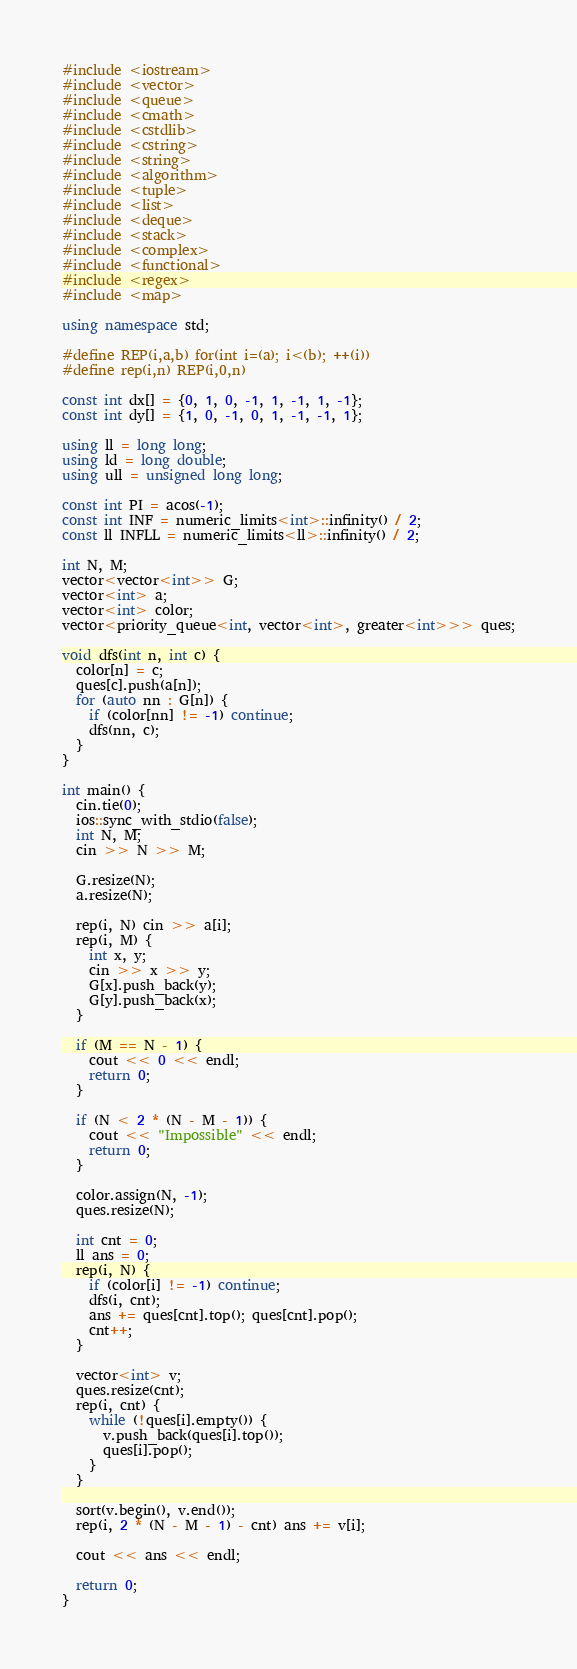<code> <loc_0><loc_0><loc_500><loc_500><_C++_>#include <iostream>
#include <vector>
#include <queue>
#include <cmath>
#include <cstdlib>
#include <cstring>
#include <string>
#include <algorithm>
#include <tuple>
#include <list>
#include <deque>
#include <stack>
#include <complex>
#include <functional>
#include <regex>
#include <map>

using namespace std;

#define REP(i,a,b) for(int i=(a); i<(b); ++(i))
#define rep(i,n) REP(i,0,n)

const int dx[] = {0, 1, 0, -1, 1, -1, 1, -1};
const int dy[] = {1, 0, -1, 0, 1, -1, -1, 1};

using ll = long long;
using ld = long double;
using ull = unsigned long long;

const int PI = acos(-1);
const int INF = numeric_limits<int>::infinity() / 2;
const ll INFLL = numeric_limits<ll>::infinity() / 2;

int N, M;
vector<vector<int>> G;
vector<int> a;
vector<int> color;
vector<priority_queue<int, vector<int>, greater<int>>> ques;

void dfs(int n, int c) {
  color[n] = c;
  ques[c].push(a[n]);
  for (auto nn : G[n]) {
    if (color[nn] != -1) continue;
    dfs(nn, c);
  }
}

int main() {
  cin.tie(0);
  ios::sync_with_stdio(false);
  int N, M;
  cin >> N >> M;

  G.resize(N);
  a.resize(N);

  rep(i, N) cin >> a[i];
  rep(i, M) {
    int x, y;
    cin >> x >> y;
    G[x].push_back(y);
    G[y].push_back(x);
  }

  if (M == N - 1) {
    cout << 0 << endl;
    return 0;
  }

  if (N < 2 * (N - M - 1)) {
    cout << "Impossible" << endl;
    return 0;
  }

  color.assign(N, -1);
  ques.resize(N);

  int cnt = 0;
  ll ans = 0;
  rep(i, N) {
    if (color[i] != -1) continue;
    dfs(i, cnt);
    ans += ques[cnt].top(); ques[cnt].pop();
    cnt++;
  }

  vector<int> v;
  ques.resize(cnt);
  rep(i, cnt) {
    while (!ques[i].empty()) {
      v.push_back(ques[i].top());
      ques[i].pop();
    }
  }

  sort(v.begin(), v.end());
  rep(i, 2 * (N - M - 1) - cnt) ans += v[i];

  cout << ans << endl;

  return 0;
}</code> 